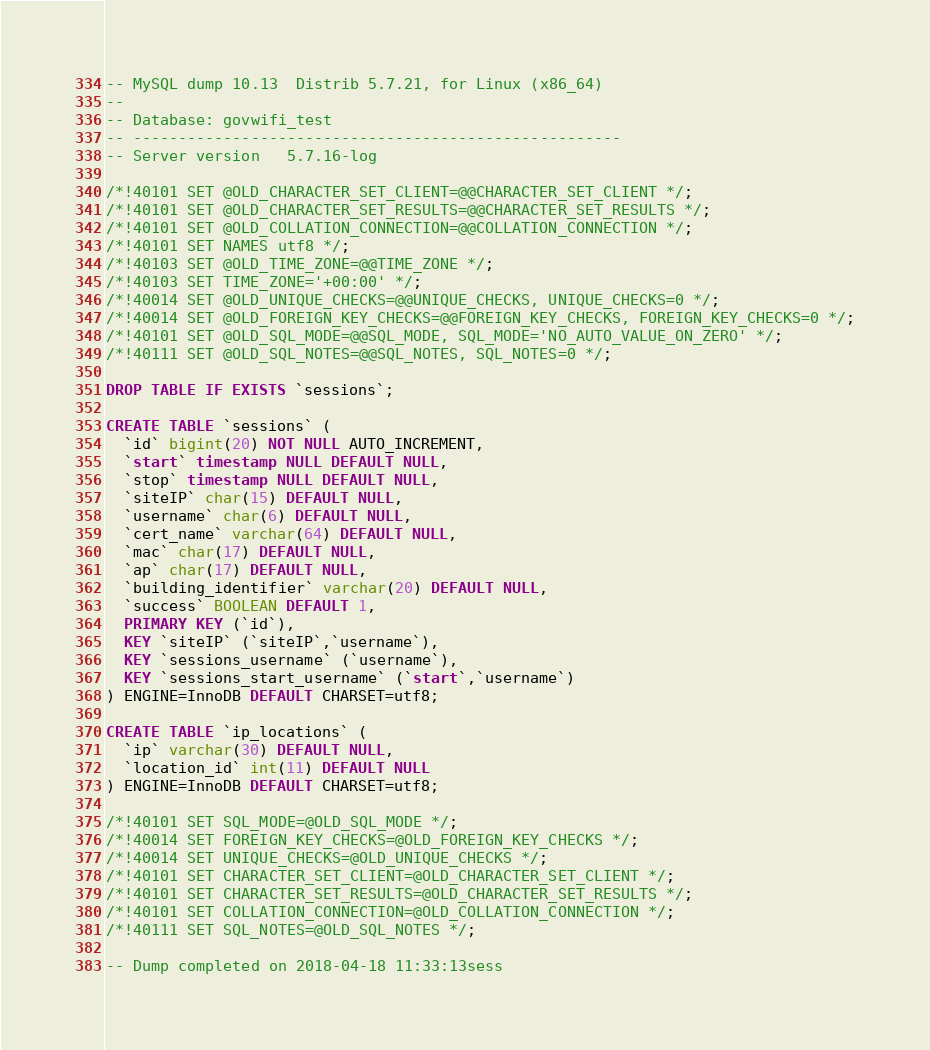<code> <loc_0><loc_0><loc_500><loc_500><_SQL_>-- MySQL dump 10.13  Distrib 5.7.21, for Linux (x86_64)
--
-- Database: govwifi_test
-- ------------------------------------------------------
-- Server version	5.7.16-log

/*!40101 SET @OLD_CHARACTER_SET_CLIENT=@@CHARACTER_SET_CLIENT */;
/*!40101 SET @OLD_CHARACTER_SET_RESULTS=@@CHARACTER_SET_RESULTS */;
/*!40101 SET @OLD_COLLATION_CONNECTION=@@COLLATION_CONNECTION */;
/*!40101 SET NAMES utf8 */;
/*!40103 SET @OLD_TIME_ZONE=@@TIME_ZONE */;
/*!40103 SET TIME_ZONE='+00:00' */;
/*!40014 SET @OLD_UNIQUE_CHECKS=@@UNIQUE_CHECKS, UNIQUE_CHECKS=0 */;
/*!40014 SET @OLD_FOREIGN_KEY_CHECKS=@@FOREIGN_KEY_CHECKS, FOREIGN_KEY_CHECKS=0 */;
/*!40101 SET @OLD_SQL_MODE=@@SQL_MODE, SQL_MODE='NO_AUTO_VALUE_ON_ZERO' */;
/*!40111 SET @OLD_SQL_NOTES=@@SQL_NOTES, SQL_NOTES=0 */;

DROP TABLE IF EXISTS `sessions`;

CREATE TABLE `sessions` (
  `id` bigint(20) NOT NULL AUTO_INCREMENT,
  `start` timestamp NULL DEFAULT NULL,
  `stop` timestamp NULL DEFAULT NULL,
  `siteIP` char(15) DEFAULT NULL,
  `username` char(6) DEFAULT NULL,
  `cert_name` varchar(64) DEFAULT NULL,
  `mac` char(17) DEFAULT NULL,
  `ap` char(17) DEFAULT NULL,
  `building_identifier` varchar(20) DEFAULT NULL,
  `success` BOOLEAN DEFAULT 1,
  PRIMARY KEY (`id`),
  KEY `siteIP` (`siteIP`,`username`),
  KEY `sessions_username` (`username`),
  KEY `sessions_start_username` (`start`,`username`)
) ENGINE=InnoDB DEFAULT CHARSET=utf8;

CREATE TABLE `ip_locations` (
  `ip` varchar(30) DEFAULT NULL,
  `location_id` int(11) DEFAULT NULL
) ENGINE=InnoDB DEFAULT CHARSET=utf8;

/*!40101 SET SQL_MODE=@OLD_SQL_MODE */;
/*!40014 SET FOREIGN_KEY_CHECKS=@OLD_FOREIGN_KEY_CHECKS */;
/*!40014 SET UNIQUE_CHECKS=@OLD_UNIQUE_CHECKS */;
/*!40101 SET CHARACTER_SET_CLIENT=@OLD_CHARACTER_SET_CLIENT */;
/*!40101 SET CHARACTER_SET_RESULTS=@OLD_CHARACTER_SET_RESULTS */;
/*!40101 SET COLLATION_CONNECTION=@OLD_COLLATION_CONNECTION */;
/*!40111 SET SQL_NOTES=@OLD_SQL_NOTES */;

-- Dump completed on 2018-04-18 11:33:13sess
</code> 